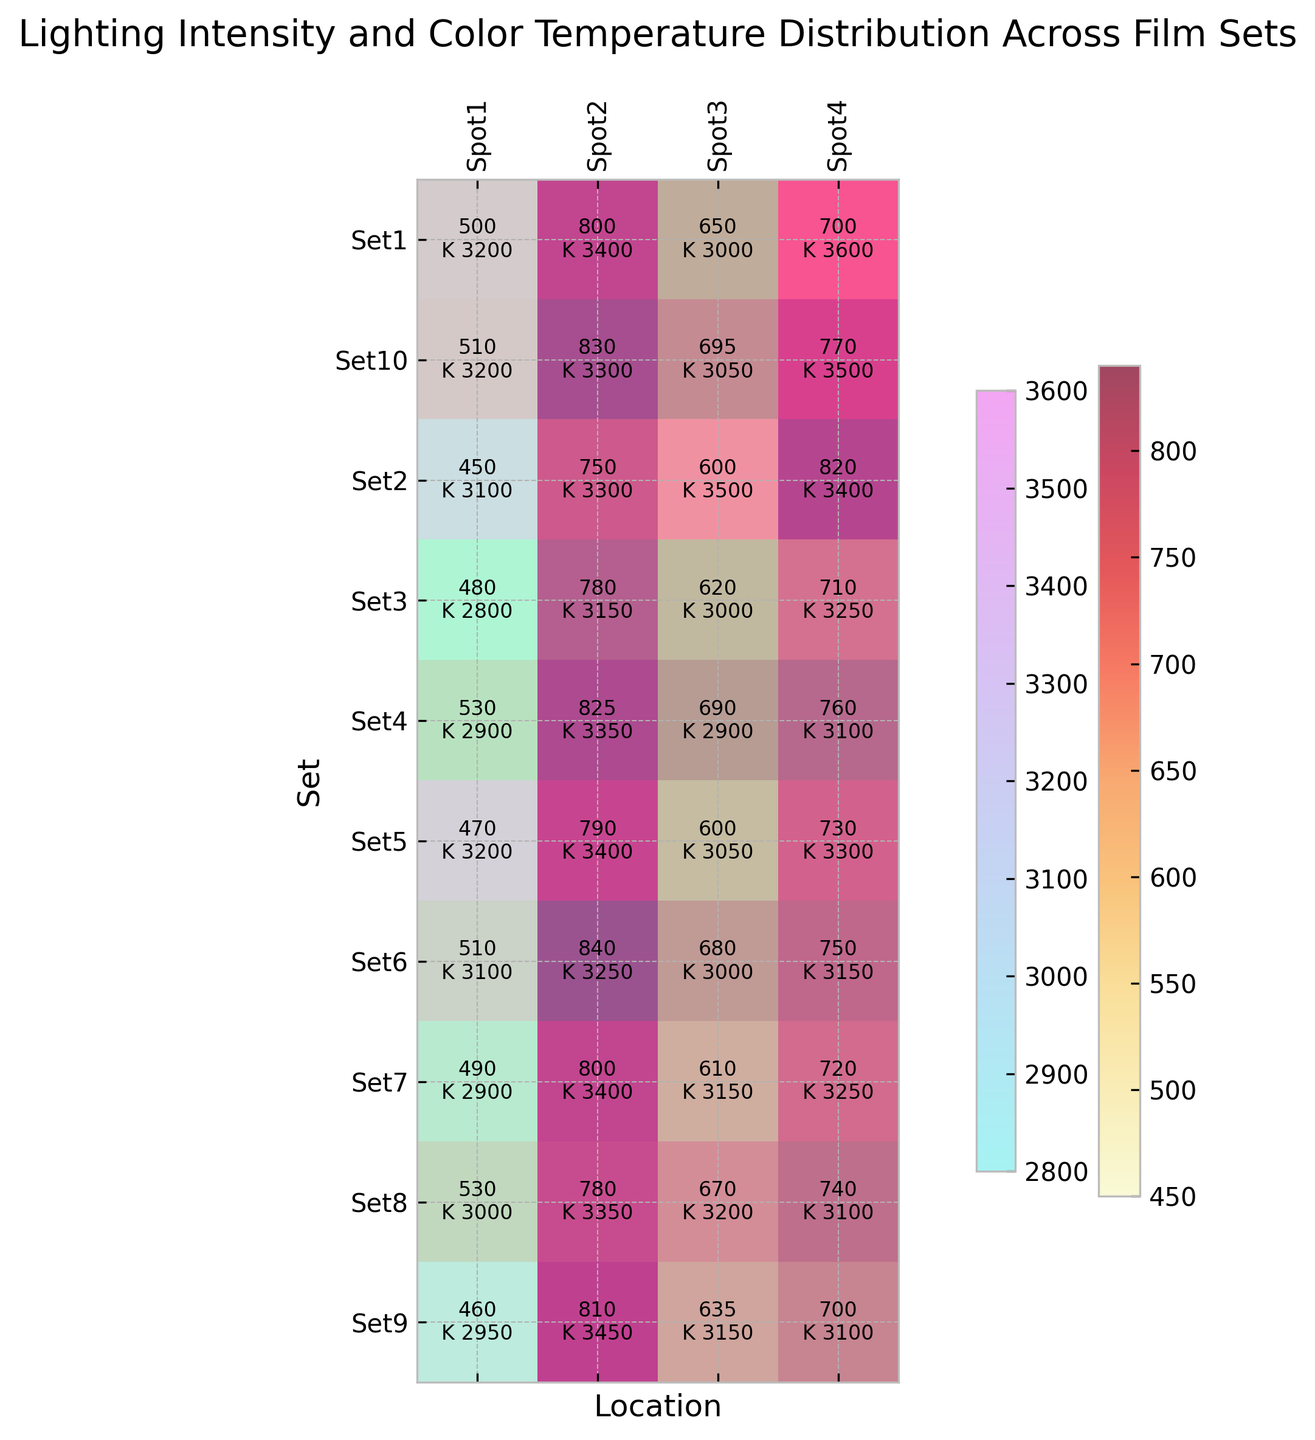What set and location combination has the highest lighting intensity? Examine the heatmap focusing on the values of lighting intensity and finding the highest number. Set6 and Spot2 have the highest lighting intensity of 840 lux.
Answer: Set6 and Spot2 Which location has the most consistent color temperature across all sets? Look at each column in the heatmap and see which location has the smallest range of color temperature values. Spot3 has color temperatures ranging between 2900K to 3500K, indicating less variation compared to others.
Answer: Spot3 Is there any set with all locations having color temperatures below 3000K? Check each row in the heatmap to find if any set has all entries in the color temperature below 3000K. None of the sets meet this criterion as they all have at least one value above 3000K.
Answer: No What is the average lighting intensity in Set4? Add the lighting intensities for Set4 (530 + 825 + 690 + 760) and divide by 4. The sum is 2805 lux, and the average is 2805/4, resulting in 701.25 lux.
Answer: 701.25 lux Which set has the highest average color temperature across all locations? Calculate the average color temperature for each set and compare. Set10 has the highest average color temperature: (3200 + 3300 + 3050 + 3500) / 4 = 3262.5 K.
Answer: Set10 Between Set2 and Set8, which has a higher maximum lighting intensity value? Compare the maximum lighting intensity values for Set2 (820 lux) and Set8 (780 lux). Set2 has a higher maximum value of 820 lux.
Answer: Set2 Which set and location combination has the lowest color temperature? Examine the heatmap for color temperature values to find the lowest number. Set3 and Spot1 have the lowest color temperature of 2800K.
Answer: Set3 and Spot1 Does Spot4 generally have higher lighting intensity compared to Spot1 across all sets? Compare the lighting intensity values of Spot4 and Spot1 across all sets. Spot4 generally has higher or equal lighting intensity than Spot1 except in Set1 and Set9.
Answer: Generally, yes 